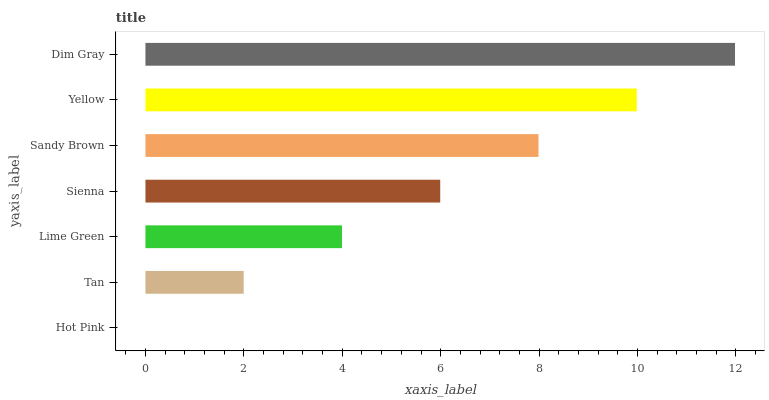Is Hot Pink the minimum?
Answer yes or no. Yes. Is Dim Gray the maximum?
Answer yes or no. Yes. Is Tan the minimum?
Answer yes or no. No. Is Tan the maximum?
Answer yes or no. No. Is Tan greater than Hot Pink?
Answer yes or no. Yes. Is Hot Pink less than Tan?
Answer yes or no. Yes. Is Hot Pink greater than Tan?
Answer yes or no. No. Is Tan less than Hot Pink?
Answer yes or no. No. Is Sienna the high median?
Answer yes or no. Yes. Is Sienna the low median?
Answer yes or no. Yes. Is Dim Gray the high median?
Answer yes or no. No. Is Lime Green the low median?
Answer yes or no. No. 